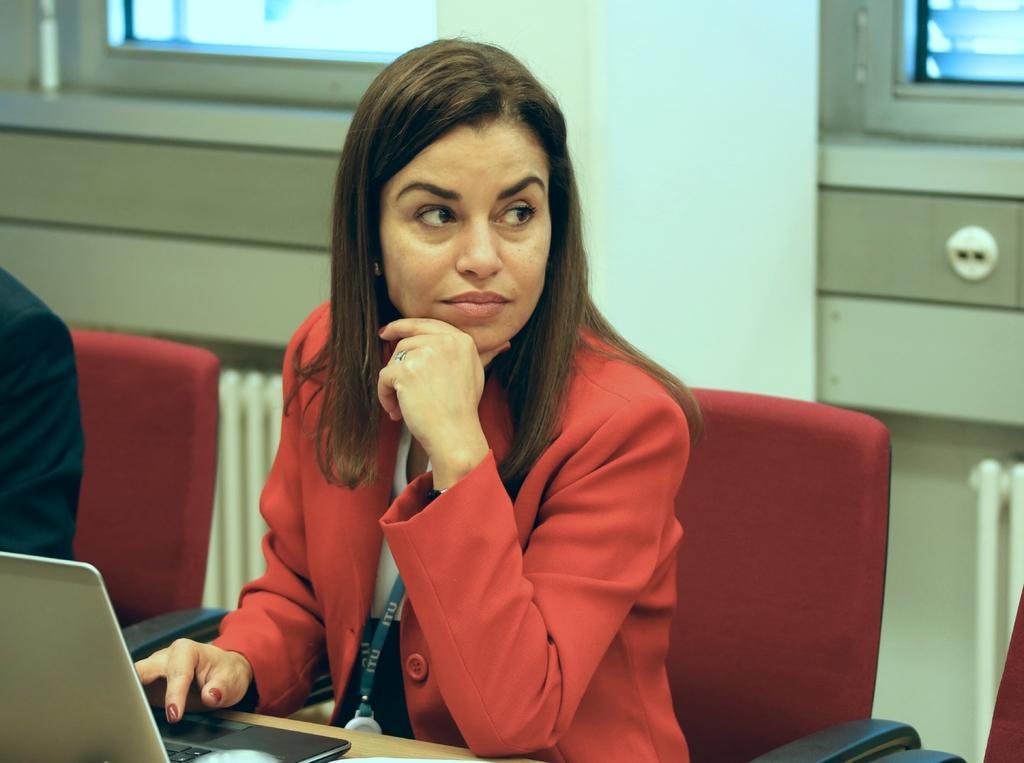How would you summarize this image in a sentence or two? In this picture we can see two people sitting on chairs were a woman wore a blazer, id card and in front of them we can see a laptop on the table and in the background we can see windows and some objects. 